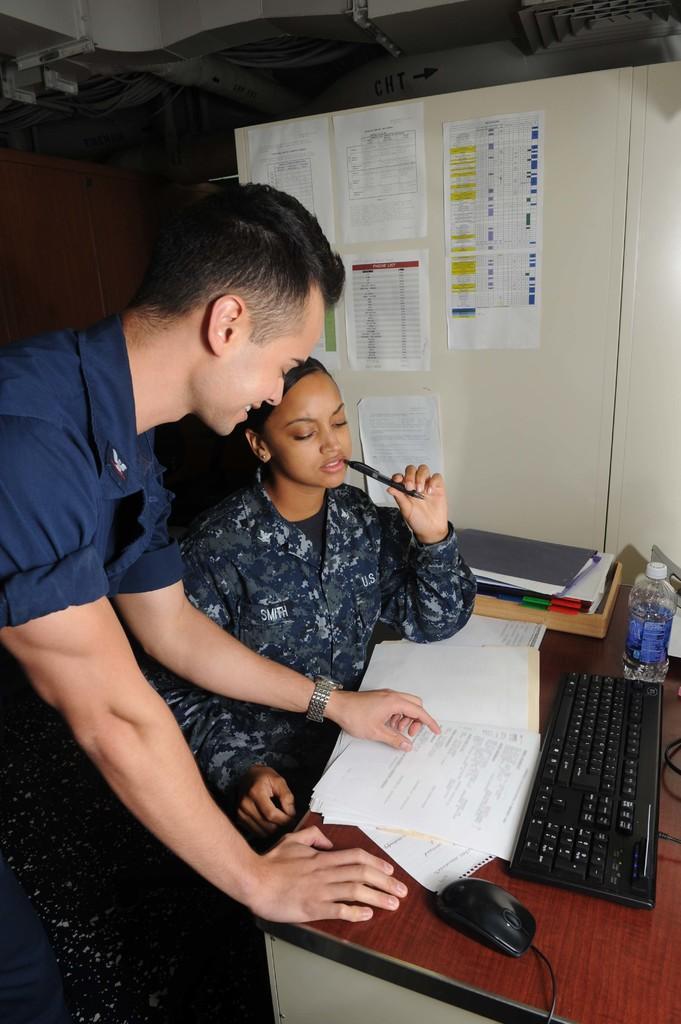Could you give a brief overview of what you see in this image? In this picture we can see man standing and smiling and beside to his woman sitting holding pen with her hand and in front of them on table we have mouse, keyboard, bottle, tray with books in it, papers, wires and in background we can see wall with posters. 